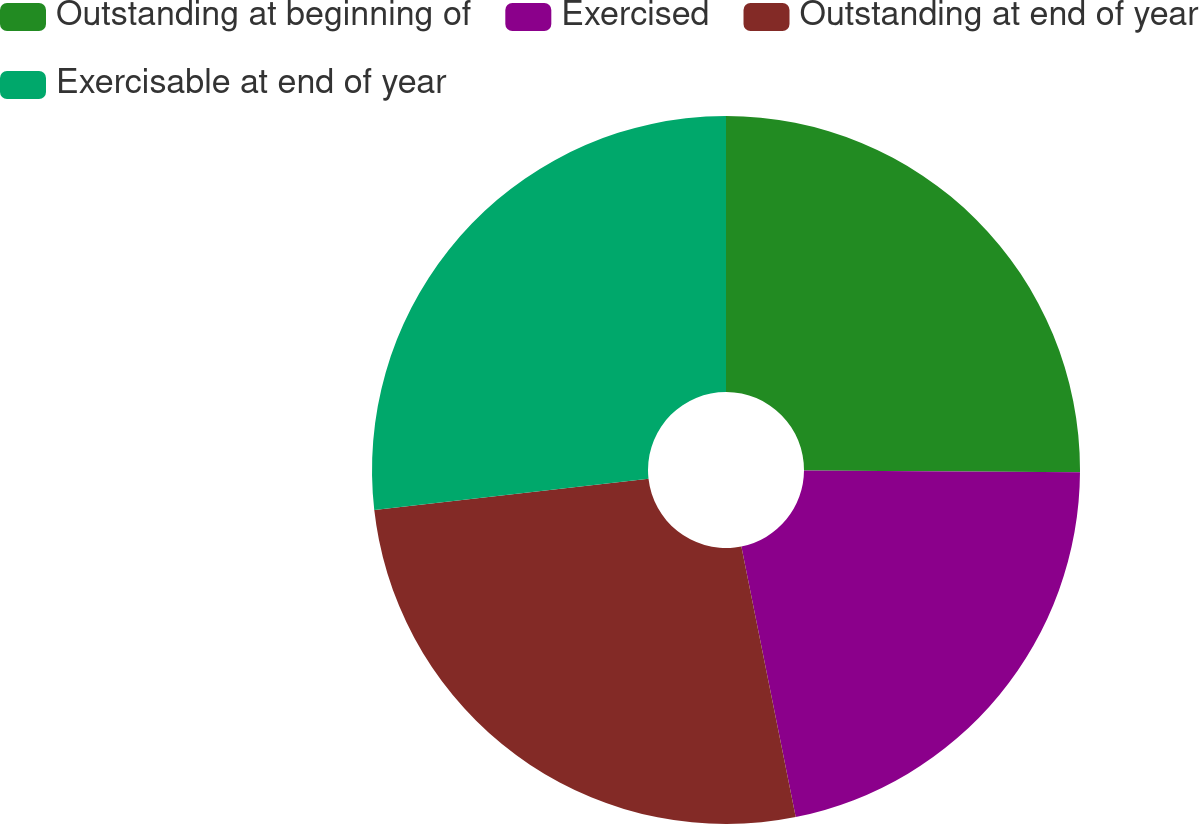<chart> <loc_0><loc_0><loc_500><loc_500><pie_chart><fcel>Outstanding at beginning of<fcel>Exercised<fcel>Outstanding at end of year<fcel>Exercisable at end of year<nl><fcel>25.1%<fcel>21.75%<fcel>26.35%<fcel>26.81%<nl></chart> 